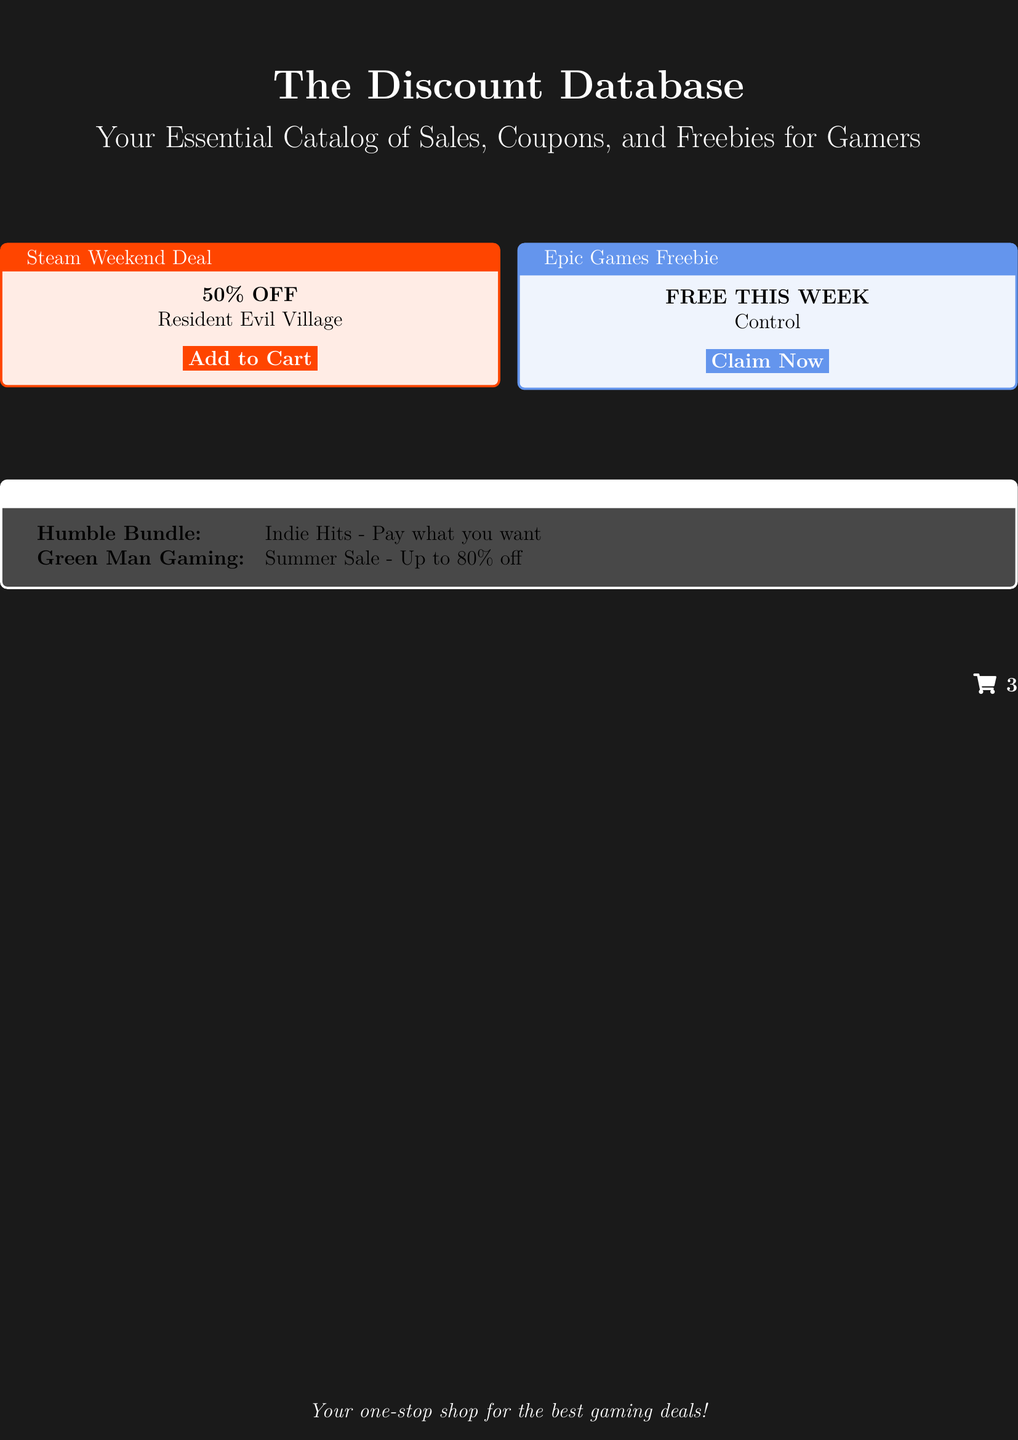What is the title of the book? The title of the book is prominently displayed at the top of the cover.
Answer: The Discount Database What is the subtitle of the book? The subtitle can be found just below the title and indicates the book's focus for gamers.
Answer: Your Essential Catalog of Sales, Coupons, and Freebies for Gamers What is the discount for Resident Evil Village? The discount for the game is stated inside a colorful box noting current deals.
Answer: 50% OFF What is available for free this week? The free game offered this week is listed in a separate section for Epic Games freebies.
Answer: Control What is the Humble Bundle sale deal? The Humble Bundle deal is shared as part of the hot deals section of the document.
Answer: Pay what you want What is the maximum discount at Green Man Gaming? The maximum discount offered is mentioned in relation to the summer sale.
Answer: Up to 80% off How many items are currently in the shopping cart? The shopping cart icon indicates the number of items added for purchase.
Answer: 3 What color is used for the Steam Weekend Deal box? The color of the box for the Steam Weekend Deal is specified in the document's design.
Answer: Orange What does the document describe as a one-stop shop? The last line in the document encapsulates the overall purpose of the book.
Answer: Your one-stop shop for the best gaming deals! 